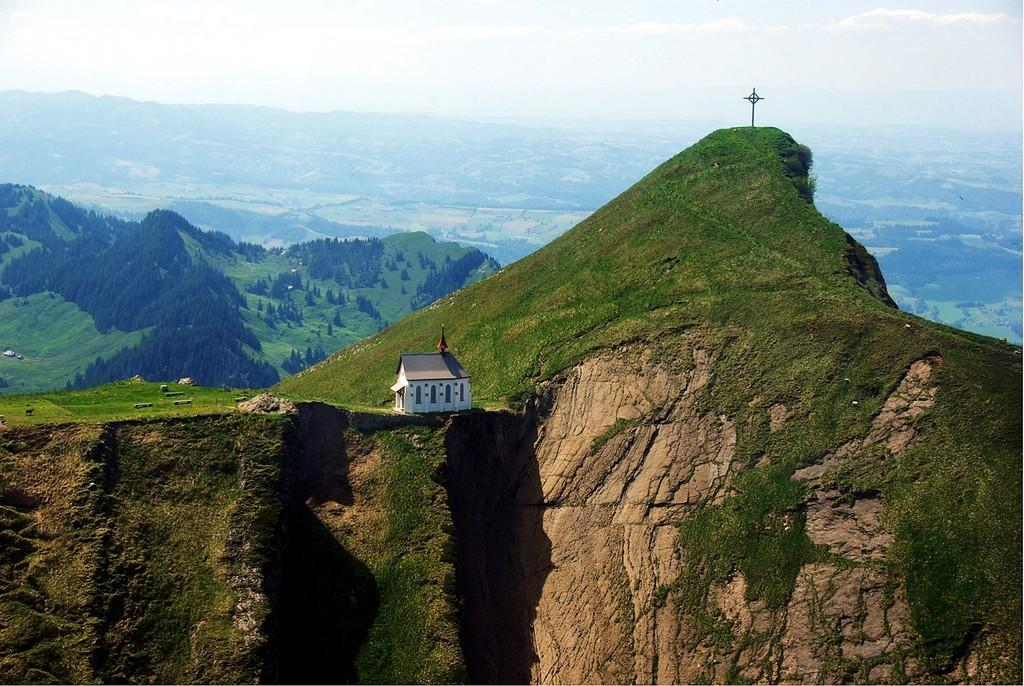What is the main subject in the center of the image? There is a house in the center of the image. Can you describe the house's structure? The house has a wall and a roof. What can be seen in the background of the image? There is sky, clouds, a mountain, a cross, trees, plants, and grass visible in the background of the image. How many people are going on vacation in the image? There is no indication of anyone going on vacation in the image; it primarily features a house and its surroundings. 